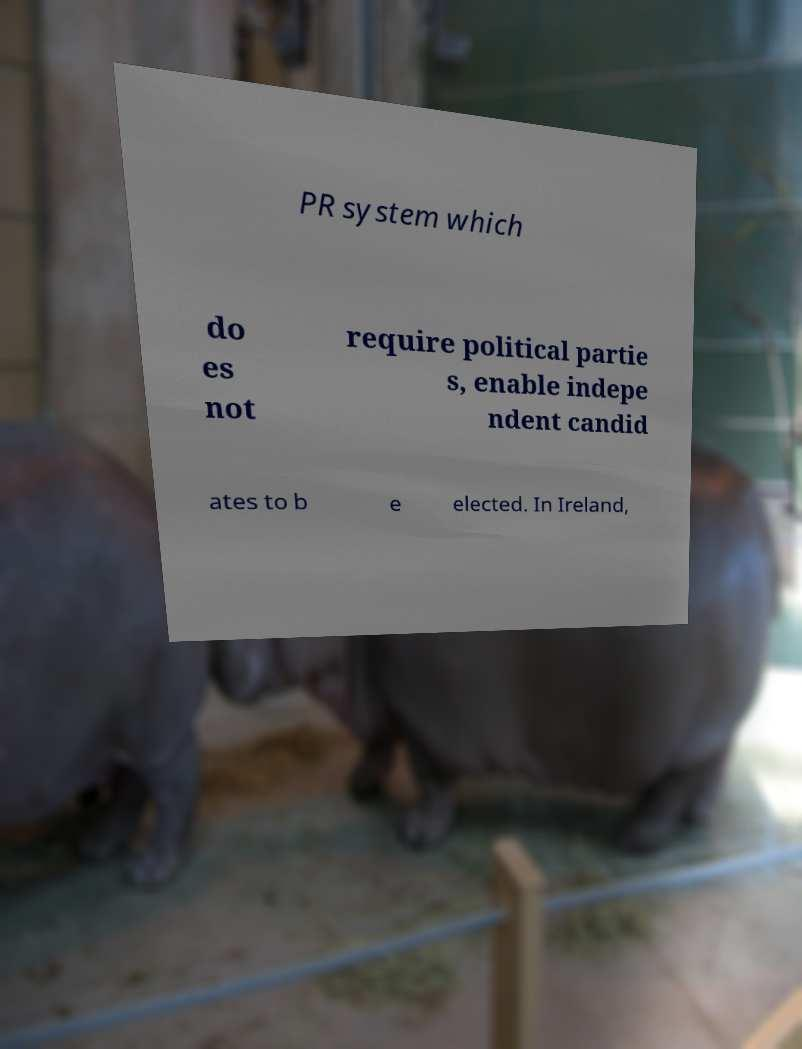For documentation purposes, I need the text within this image transcribed. Could you provide that? PR system which do es not require political partie s, enable indepe ndent candid ates to b e elected. In Ireland, 